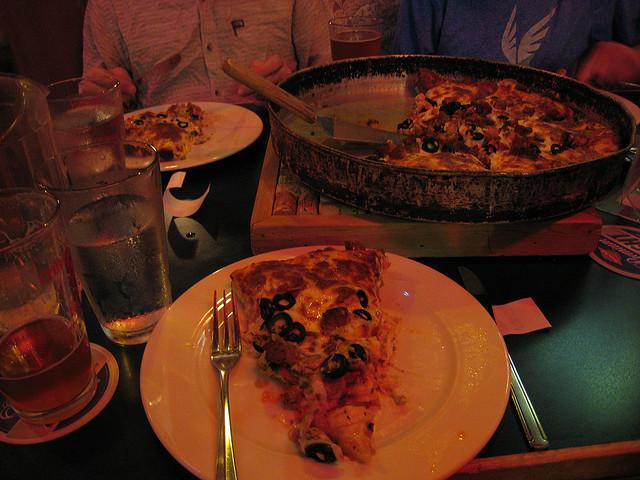What is on the pizza? olives 